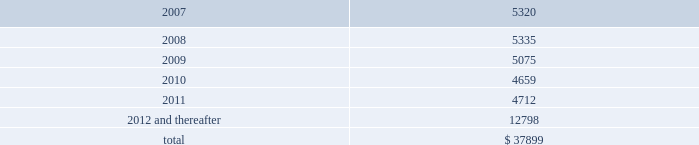As of december 31 , 2006 , the company also leased an office and laboratory facility in connecticut , additional office , distribution and storage facilities in san diego , and four foreign facilities located in japan , singapore , china and the netherlands under non-cancelable operating leases that expire at various times through june 2011 .
These leases contain renewal options ranging from one to five years .
As of december 31 , 2006 , annual future minimum payments under these operating leases were as follows ( in thousands ) : .
Rent expense , net of amortization of the deferred gain on sale of property , was $ 4723041 , $ 4737218 , and $ 1794234 for the years ended december 31 , 2006 , january 1 , 2006 and january 2 , 2005 , respectively .
Stockholders 2019 equity common stock as of december 31 , 2006 , the company had 46857512 shares of common stock outstanding , of which 4814744 shares were sold to employees and consultants subject to restricted stock agreements .
The restricted common shares vest in accordance with the provisions of the agreements , generally over five years .
All unvested shares are subject to repurchase by the company at the original purchase price .
As of december 31 , 2006 , 36000 shares of common stock were subject to repurchase .
In addition , the company also issued 12000 shares for a restricted stock award to an employee under the company 2019s new 2005 stock and incentive plan based on service performance .
These shares vest monthly over a three-year period .
Stock options 2005 stock and incentive plan in june 2005 , the stockholders of the company approved the 2005 stock and incentive plan ( the 2005 stock plan ) .
Upon adoption of the 2005 stock plan , issuance of options under the company 2019s existing 2000 stock plan ceased .
The 2005 stock plan provides that an aggregate of up to 11542358 shares of the company 2019s common stock be reserved and available to be issued .
In addition , the 2005 stock plan provides for an automatic annual increase in the shares reserved for issuance by the lesser of 5% ( 5 % ) of outstanding shares of the company 2019s common stock on the last day of the immediately preceding fiscal year , 1200000 shares or such lesser amount as determined by the company 2019s board of directors .
Illumina , inc .
Notes to consolidated financial statements 2014 ( continued ) .
What percentage of annual future minimum payments under operating leases are due in 2007? 
Computations: (5320 / 37899)
Answer: 0.14037. 